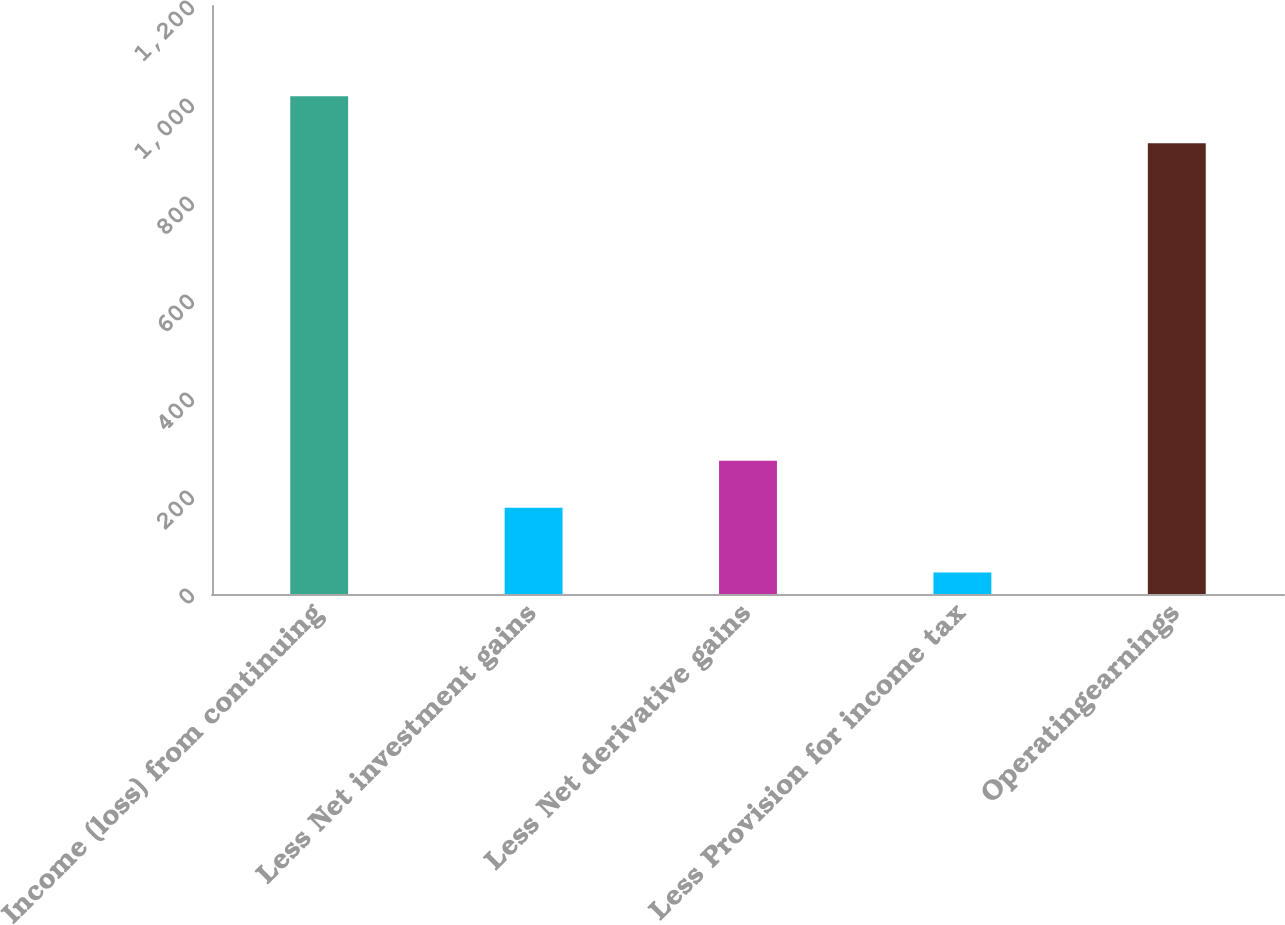Convert chart. <chart><loc_0><loc_0><loc_500><loc_500><bar_chart><fcel>Income (loss) from continuing<fcel>Less Net investment gains<fcel>Less Net derivative gains<fcel>Less Provision for income tax<fcel>Operatingearnings<nl><fcel>1015.8<fcel>176<fcel>271.8<fcel>44<fcel>920<nl></chart> 